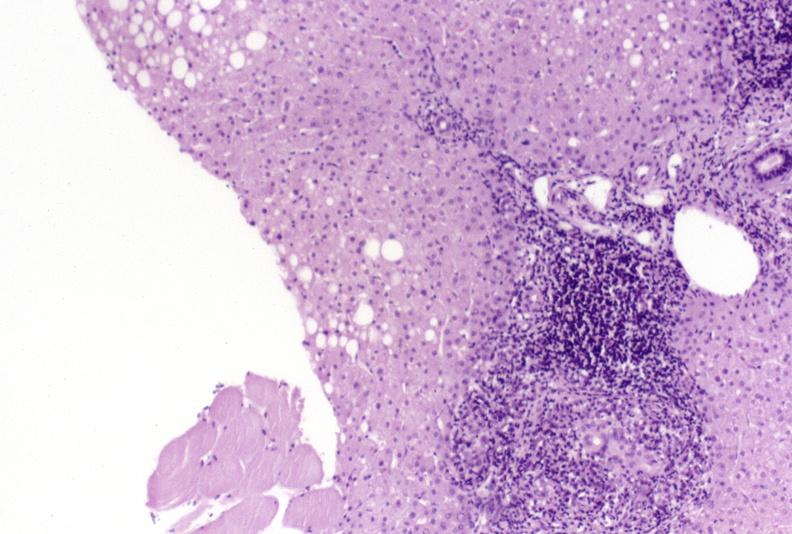s hepatobiliary present?
Answer the question using a single word or phrase. Yes 